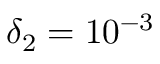<formula> <loc_0><loc_0><loc_500><loc_500>\delta _ { 2 } = 1 0 ^ { - 3 }</formula> 